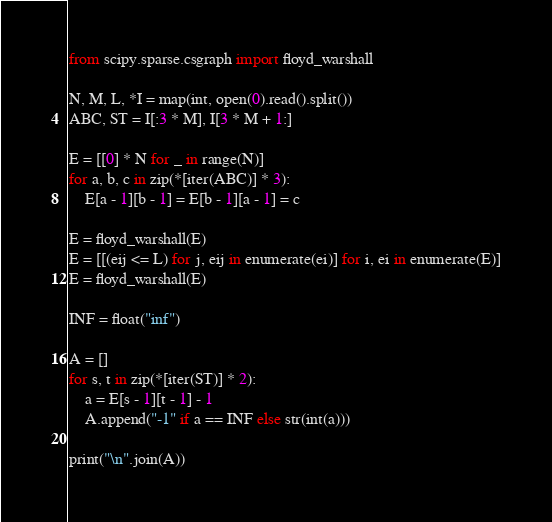<code> <loc_0><loc_0><loc_500><loc_500><_Python_>from scipy.sparse.csgraph import floyd_warshall

N, M, L, *I = map(int, open(0).read().split())
ABC, ST = I[:3 * M], I[3 * M + 1:]

E = [[0] * N for _ in range(N)]
for a, b, c in zip(*[iter(ABC)] * 3):
    E[a - 1][b - 1] = E[b - 1][a - 1] = c

E = floyd_warshall(E)
E = [[(eij <= L) for j, eij in enumerate(ei)] for i, ei in enumerate(E)]
E = floyd_warshall(E)

INF = float("inf")

A = []
for s, t in zip(*[iter(ST)] * 2):
    a = E[s - 1][t - 1] - 1
    A.append("-1" if a == INF else str(int(a)))

print("\n".join(A))
</code> 